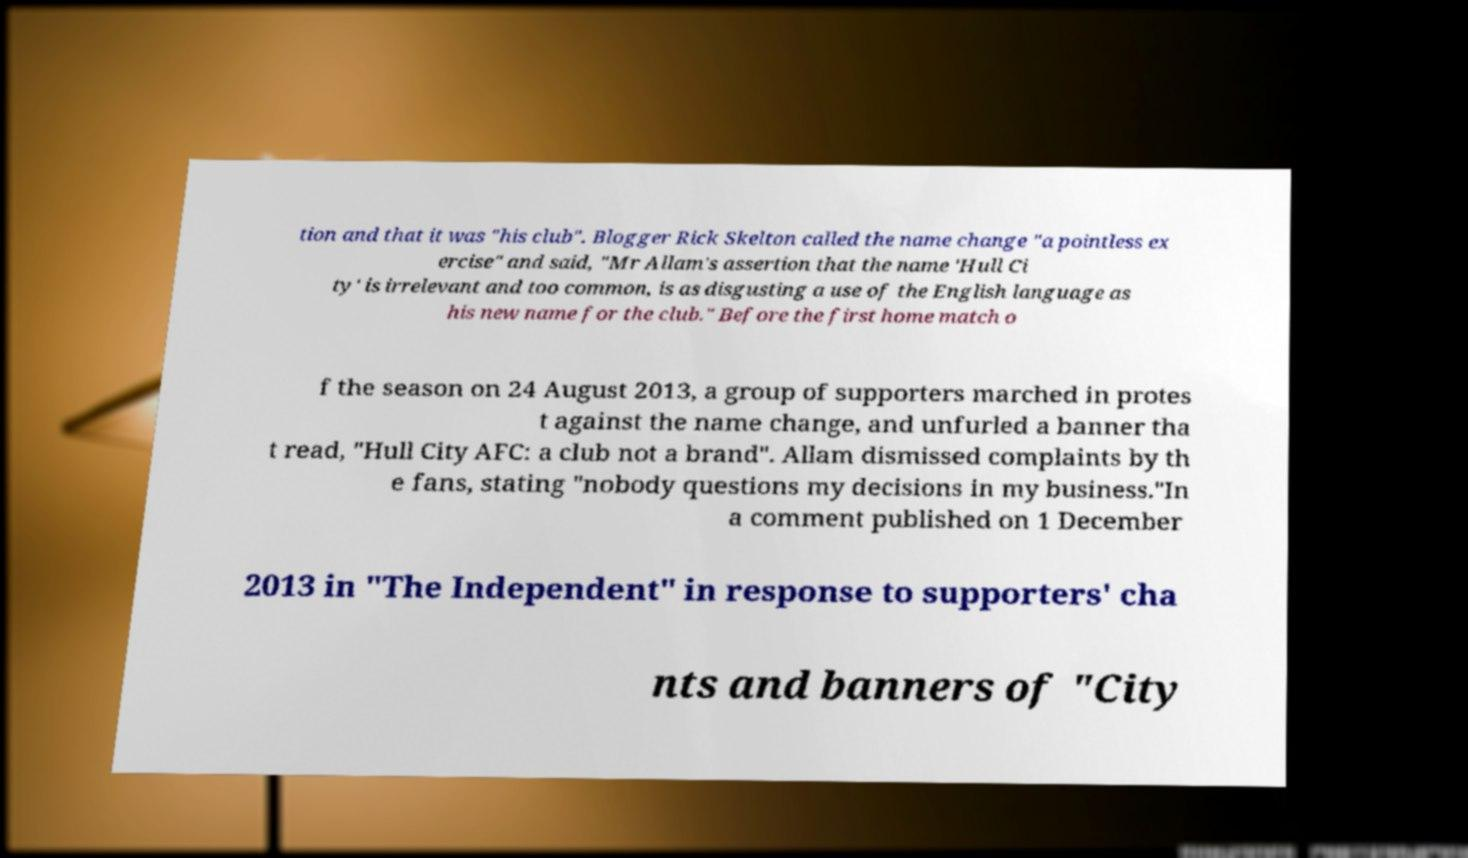Please identify and transcribe the text found in this image. tion and that it was "his club". Blogger Rick Skelton called the name change "a pointless ex ercise" and said, "Mr Allam's assertion that the name 'Hull Ci ty' is irrelevant and too common, is as disgusting a use of the English language as his new name for the club." Before the first home match o f the season on 24 August 2013, a group of supporters marched in protes t against the name change, and unfurled a banner tha t read, "Hull City AFC: a club not a brand". Allam dismissed complaints by th e fans, stating "nobody questions my decisions in my business."In a comment published on 1 December 2013 in "The Independent" in response to supporters' cha nts and banners of "City 